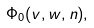Convert formula to latex. <formula><loc_0><loc_0><loc_500><loc_500>\Phi _ { 0 } ( v , w , n ) ,</formula> 